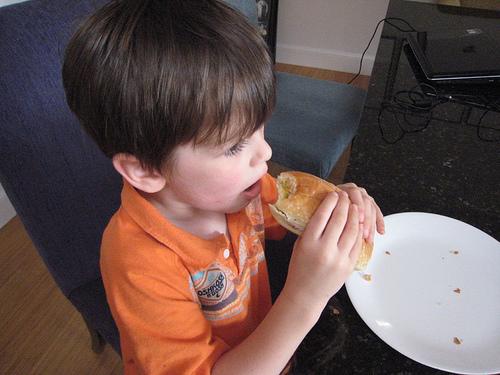Who is eating off the plate?
Give a very brief answer. Boy. Did he take the first bite already?
Write a very short answer. Yes. Are any other dishes on the boy's plate?
Quick response, please. No. What color is his shirt?
Quick response, please. Orange. 